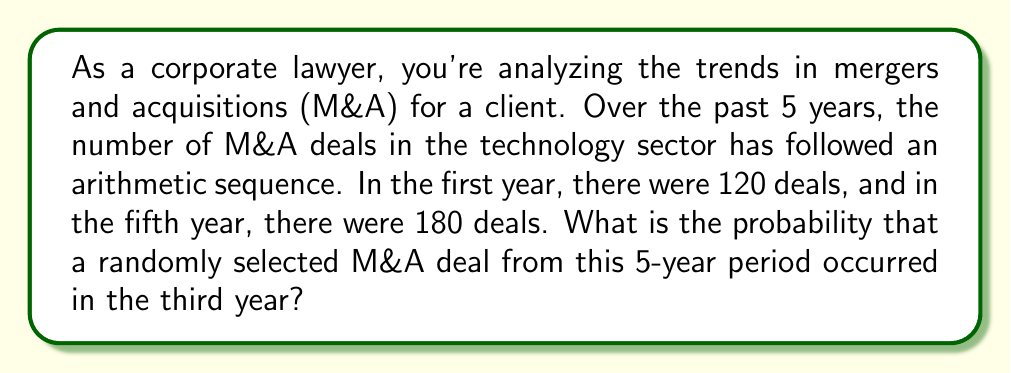Give your solution to this math problem. Let's approach this step-by-step:

1) First, we need to find the arithmetic sequence for the number of deals each year.
   - We know the first term $a_1 = 120$ and the fifth term $a_5 = 180$
   - In an arithmetic sequence, $a_n = a_1 + (n-1)d$ where $d$ is the common difference
   - So, $180 = 120 + (5-1)d$
   - $60 = 4d$
   - $d = 15$

2) Now we can calculate the number of deals for each year:
   - Year 1: $a_1 = 120$
   - Year 2: $a_2 = 120 + 15 = 135$
   - Year 3: $a_3 = 120 + 2(15) = 150$
   - Year 4: $a_4 = 120 + 3(15) = 165$
   - Year 5: $a_5 = 120 + 4(15) = 180$

3) The total number of deals over the 5 years is:
   $120 + 135 + 150 + 165 + 180 = 750$

4) The probability of a deal occurring in the third year is:
   $$P(\text{3rd year}) = \frac{\text{Number of deals in 3rd year}}{\text{Total number of deals}} = \frac{150}{750} = \frac{1}{5} = 0.2$$
Answer: The probability that a randomly selected M&A deal from this 5-year period occurred in the third year is $\frac{1}{5}$ or 0.2 or 20%. 